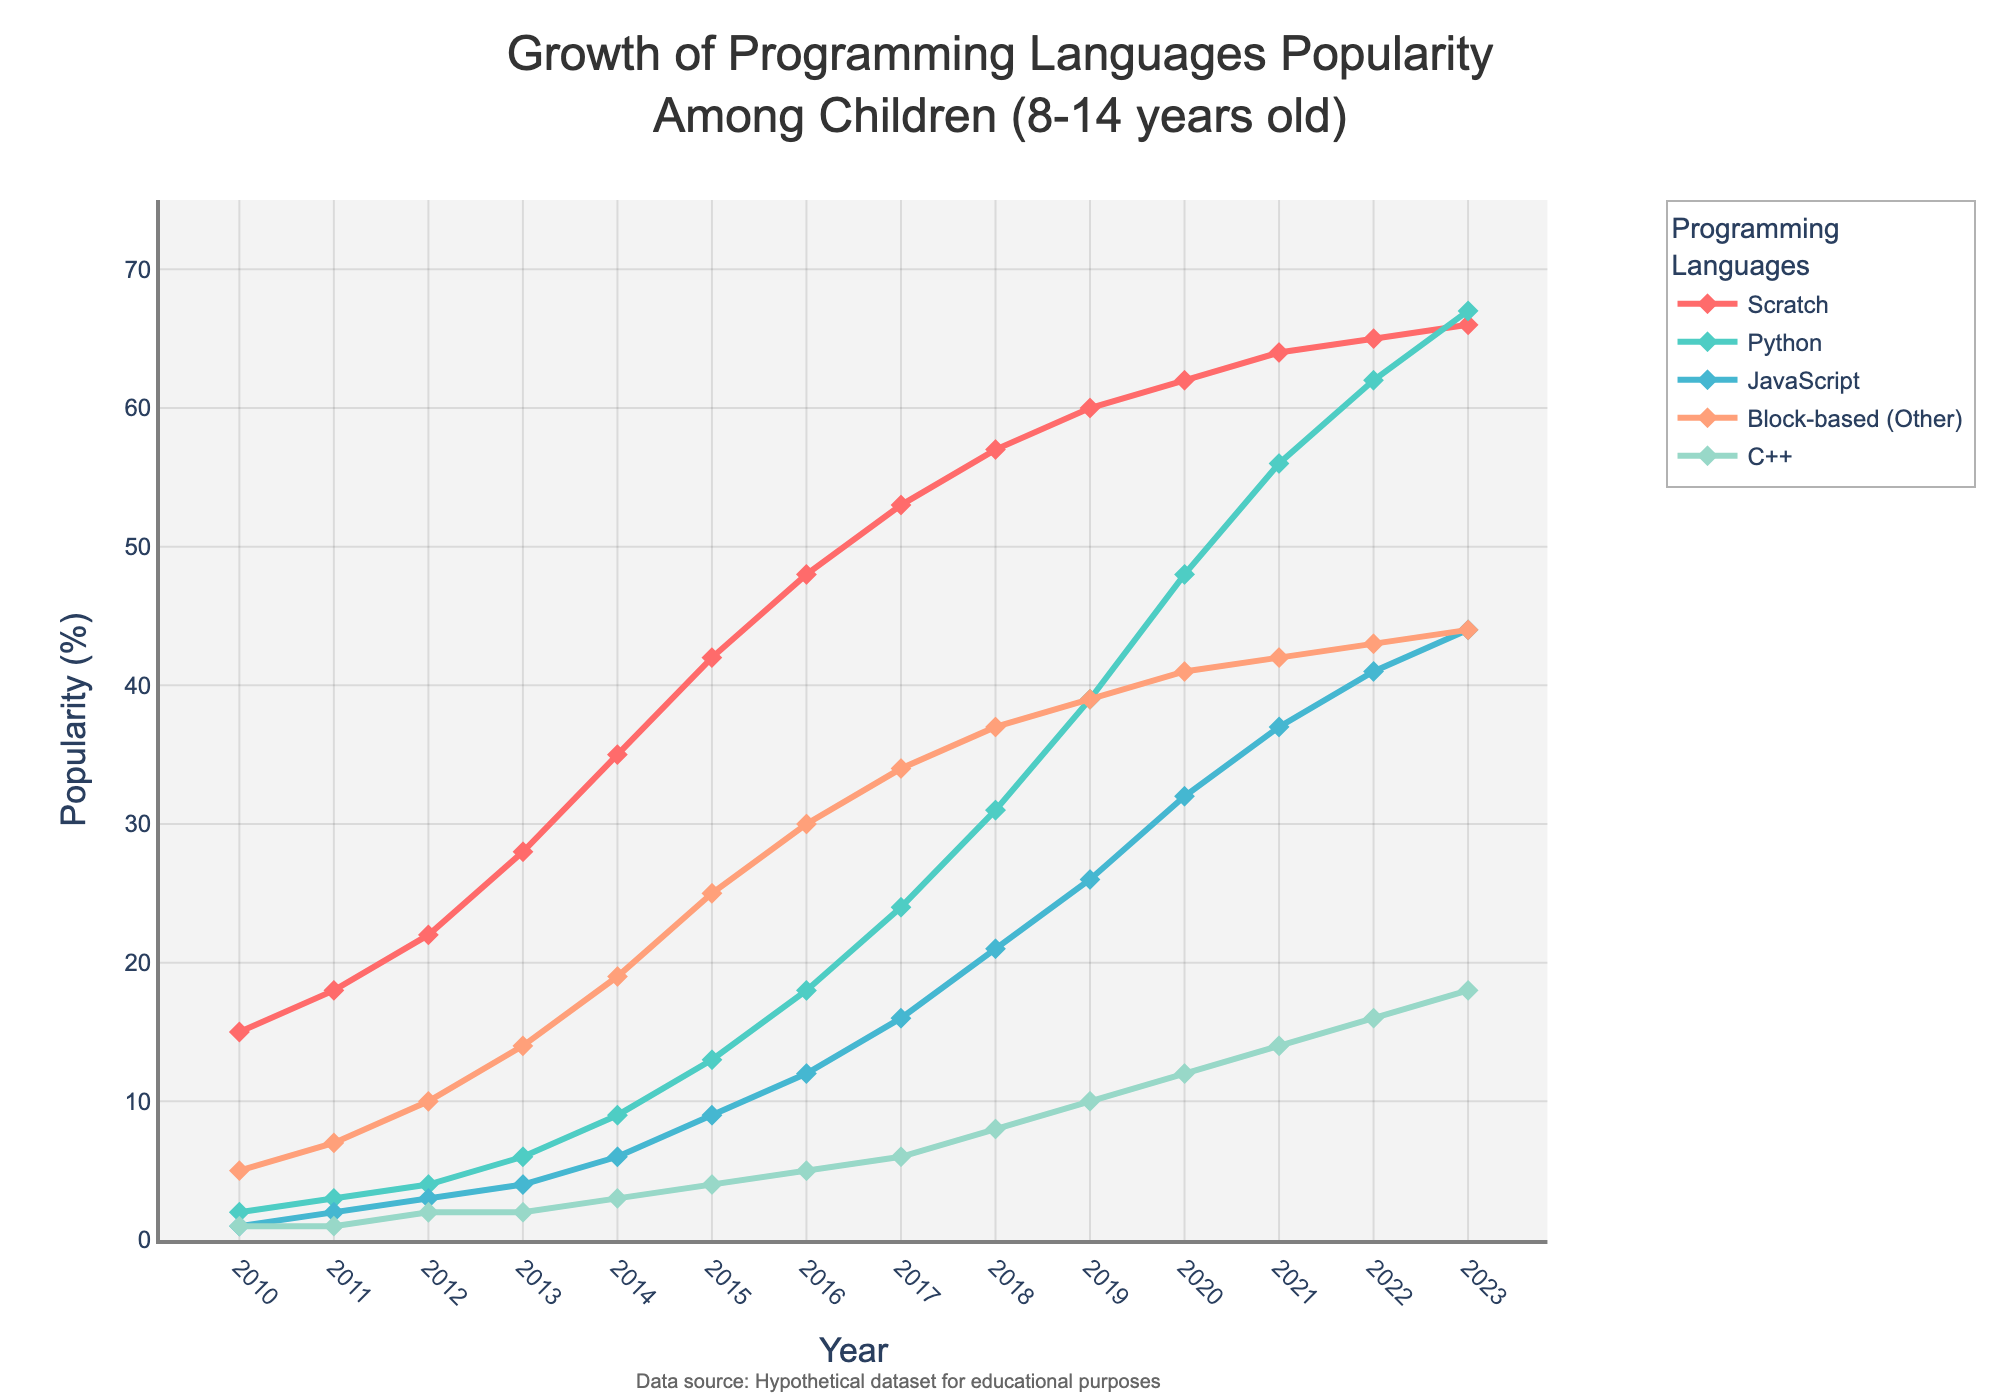What is the trend for the popularity of Scratch from 2010 to 2023? The trend line for Scratch indicates a continuous upward pattern, starting from 15% in 2010 and steadily increasing to 66% in 2023. This shows growing popularity among children over these years.
Answer: Upward trend Which programming language had the highest popularity in 2023? Upon examining the endpoints of the lines for the year 2023, we see that Scratch has the highest popularity at 66%.
Answer: Scratch How did the popularity of Python change from 2015 to 2023? In 2015, Python's popularity was 13%. By 2023, it increased significantly to 67%. The calculation is 67 - 13 = 54, indicating a substantial growth of 54 percentage points.
Answer: Increased by 54 percentage points Which programming languages showed an equal popularity in 2019? By observing the values corresponding to the year 2019, we notice that both Python and Block-based (Other) languages reached the same popularity, each at 39%.
Answer: Python and Block-based (Other) Which language grew faster from 2010 to 2023, JavaScript or C++? JavaScript started at 1% in 2010 and grew to 44% in 2023, which is an increase of 43 percentage points. C++ started at 1% and grew to 18%, an increase of 17 percentage points. JavaScript had a higher growth rate.
Answer: JavaScript What is the relative growth of Block-based (Other) programming languages between 2014 and 2021? Block-based (Other) languages were at 19% in 2014 and increased to 42% in 2021. The relative growth can be calculated by (42 - 19) / 19 = 23 / 19 ≈ 1.21, meaning approximately a 121% relative growth.
Answer: 121% During which year did Python surpass Scratch in popularity? By comparing the trend lines, we notice that Python never surpassed Scratch in popularity during any of the observed years. Scratch remained more popular throughout the entire period.
Answer: Never In what year did Python’s popularity cross the 50% mark for the first time? Looking at the plotted values for Python, the popularity surpassed 50% in the year 2021.
Answer: 2021 Comparing 2012 and 2016, by how much did Block-based (Other) programming languages increase in popularity? Block-based (Other) languages were at 10% in 2012 and increased to 30% in 2016. The difference is 30 - 10 = 20 percentage points.
Answer: 20 percentage points How many years did it take for JavaScript to reach a popularity of 20% starting from 2010? JavaScript had 1% popularity in 2010 and reached 21% in 2018. Hence, the time taken is 2018 - 2010 = 8 years.
Answer: 8 years 